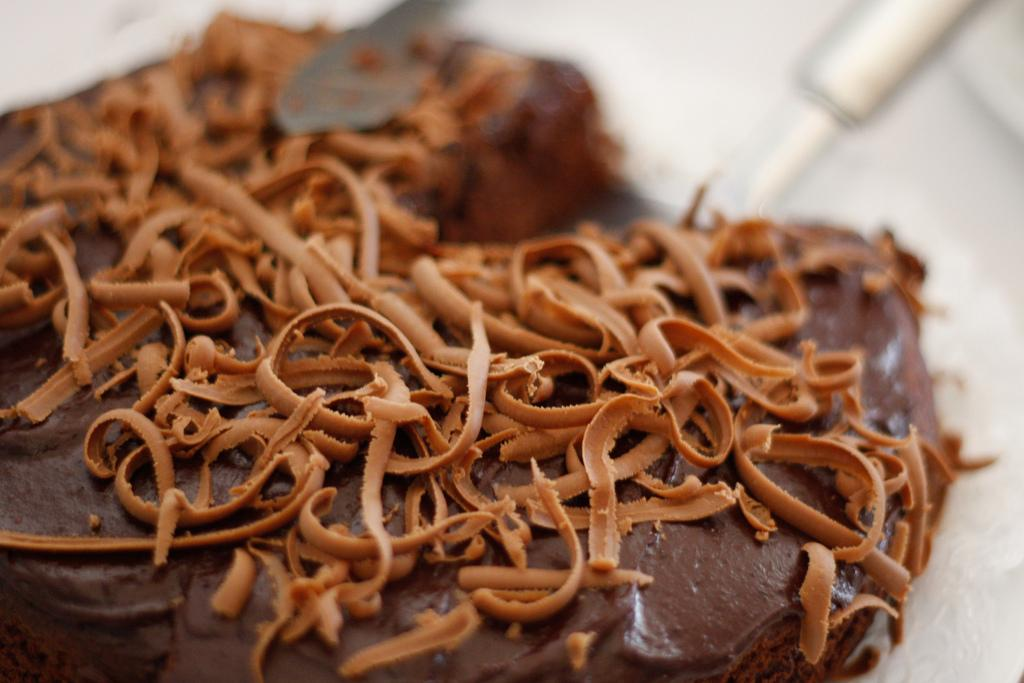What is present in the image? There are food items in the image. How are the food items arranged or presented? The food items are on chocolate. Can you describe the background of the image? The background of the image is blurred. What type of heart is visible in the image? There is no heart present in the image; it features food items on chocolate with a blurred background. 